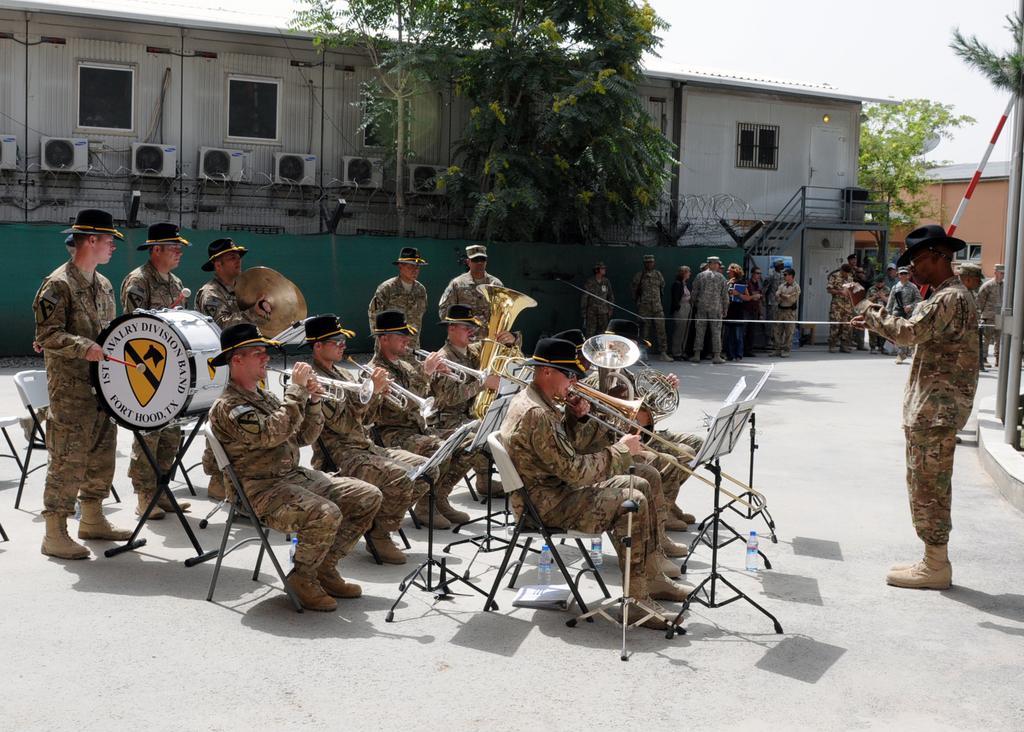How would you summarize this image in a sentence or two? In this image I can see a group of people among them some are standing and some are sitting on chairs. These people are wearing uniforms. The people over here are playing musical instruments. In the background I can see trees, building, a pole and the sky. 